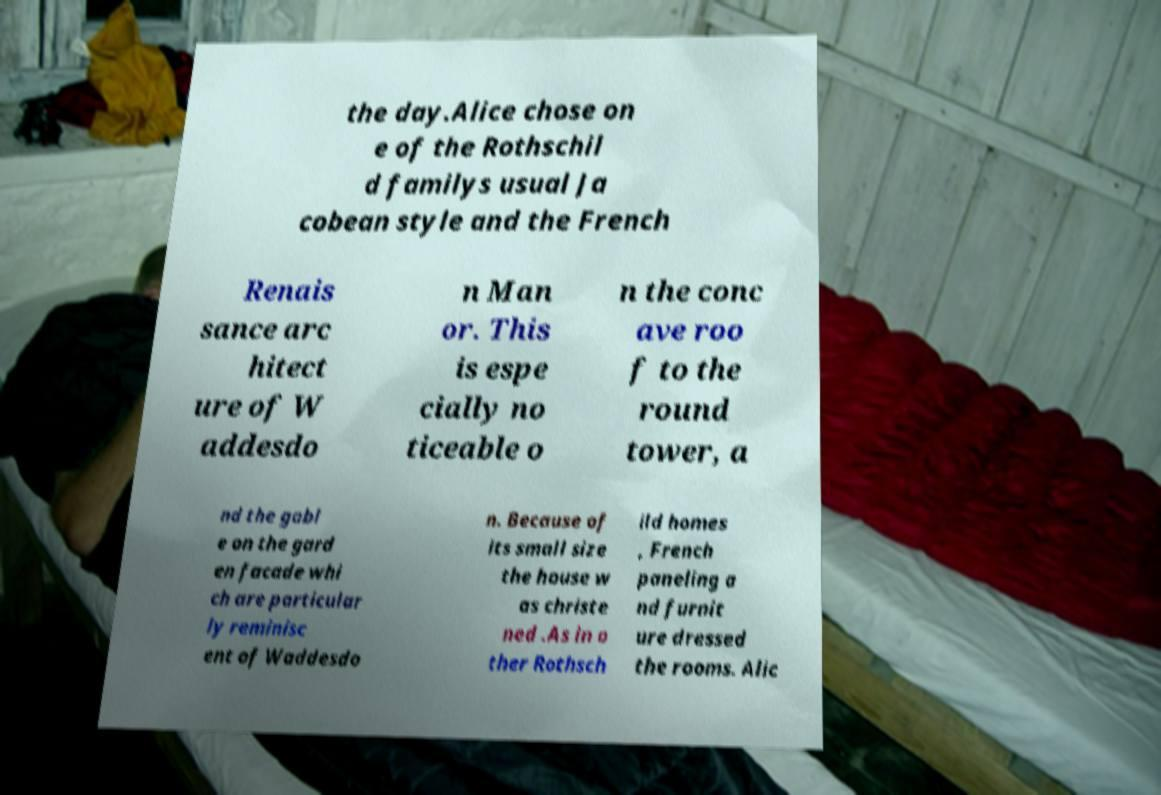I need the written content from this picture converted into text. Can you do that? the day.Alice chose on e of the Rothschil d familys usual Ja cobean style and the French Renais sance arc hitect ure of W addesdo n Man or. This is espe cially no ticeable o n the conc ave roo f to the round tower, a nd the gabl e on the gard en facade whi ch are particular ly reminisc ent of Waddesdo n. Because of its small size the house w as christe ned .As in o ther Rothsch ild homes , French paneling a nd furnit ure dressed the rooms. Alic 